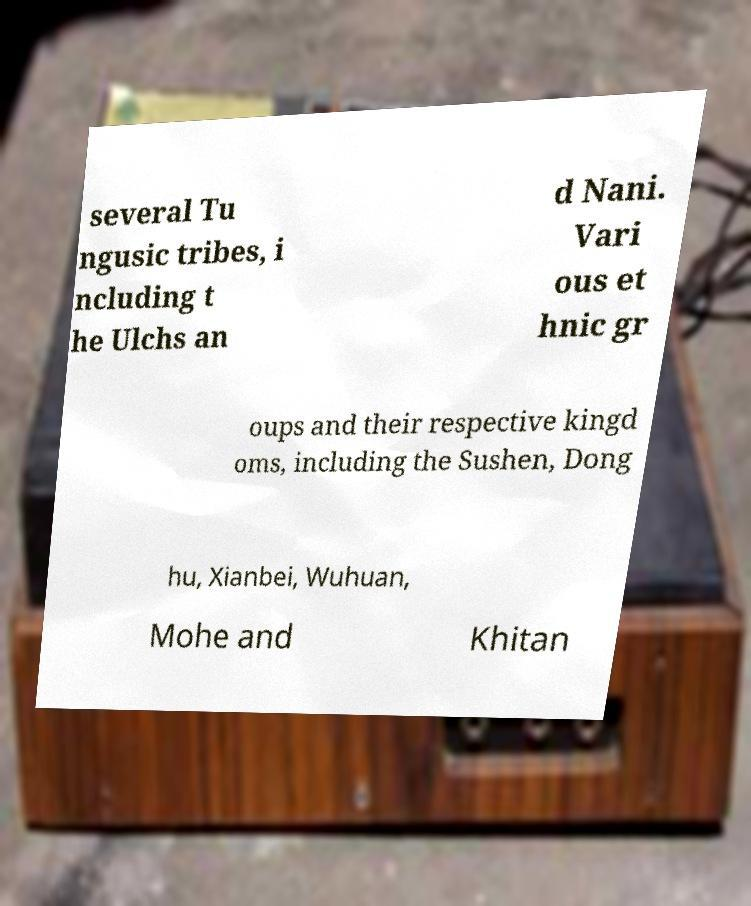Could you assist in decoding the text presented in this image and type it out clearly? several Tu ngusic tribes, i ncluding t he Ulchs an d Nani. Vari ous et hnic gr oups and their respective kingd oms, including the Sushen, Dong hu, Xianbei, Wuhuan, Mohe and Khitan 